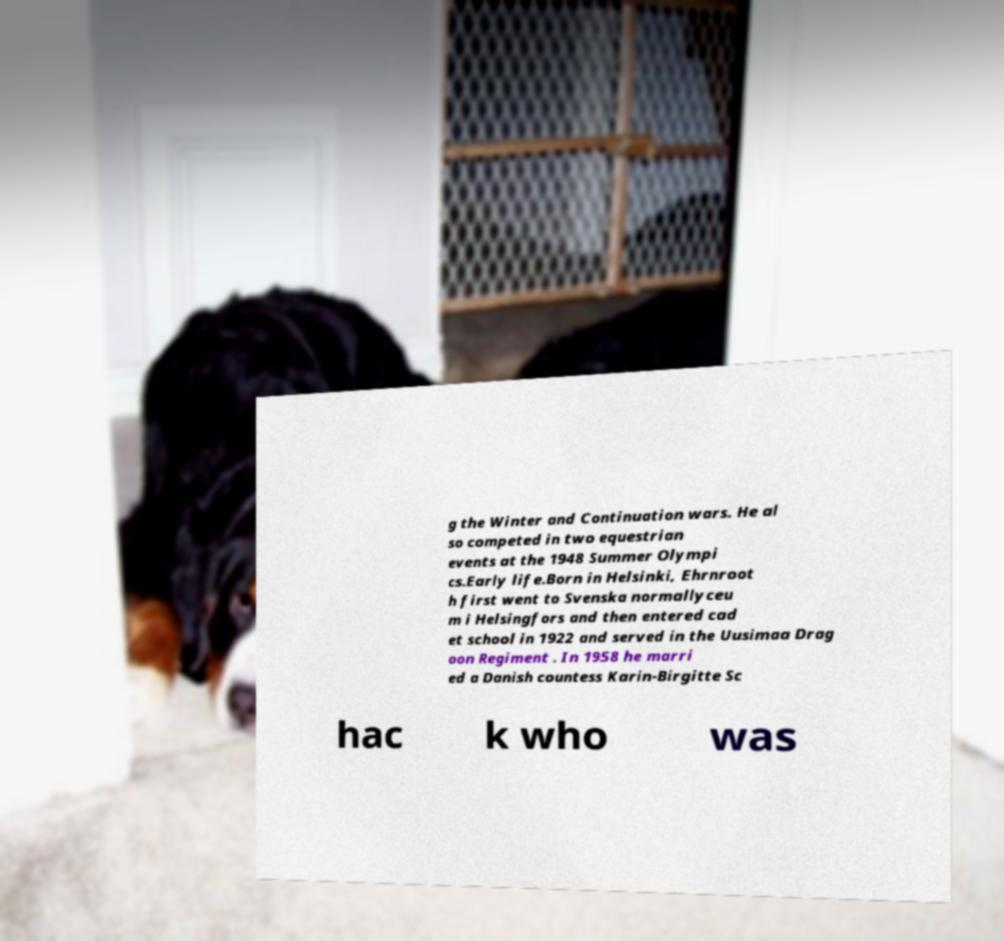Could you extract and type out the text from this image? g the Winter and Continuation wars. He al so competed in two equestrian events at the 1948 Summer Olympi cs.Early life.Born in Helsinki, Ehrnroot h first went to Svenska normallyceu m i Helsingfors and then entered cad et school in 1922 and served in the Uusimaa Drag oon Regiment . In 1958 he marri ed a Danish countess Karin-Birgitte Sc hac k who was 